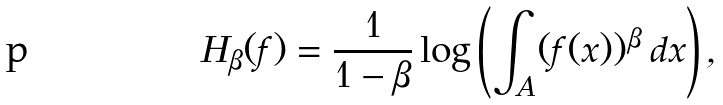Convert formula to latex. <formula><loc_0><loc_0><loc_500><loc_500>H _ { \beta } ( f ) = \frac { 1 } { 1 - \beta } \log \left ( \int _ { A } ( f ( x ) ) ^ { \beta } \, d x \right ) ,</formula> 